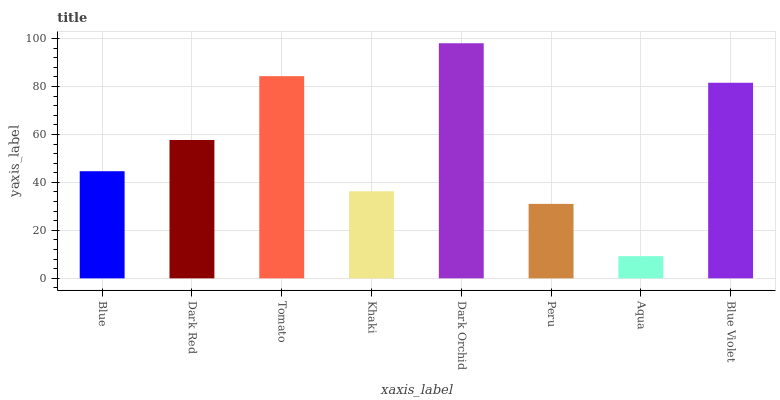Is Dark Red the minimum?
Answer yes or no. No. Is Dark Red the maximum?
Answer yes or no. No. Is Dark Red greater than Blue?
Answer yes or no. Yes. Is Blue less than Dark Red?
Answer yes or no. Yes. Is Blue greater than Dark Red?
Answer yes or no. No. Is Dark Red less than Blue?
Answer yes or no. No. Is Dark Red the high median?
Answer yes or no. Yes. Is Blue the low median?
Answer yes or no. Yes. Is Aqua the high median?
Answer yes or no. No. Is Khaki the low median?
Answer yes or no. No. 